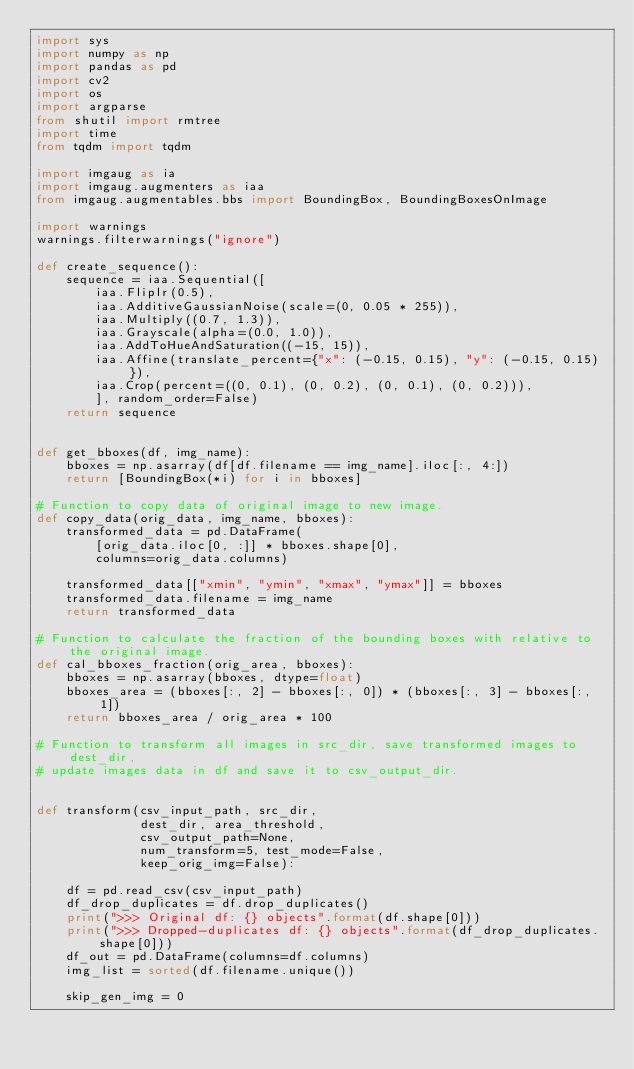<code> <loc_0><loc_0><loc_500><loc_500><_Python_>import sys
import numpy as np
import pandas as pd
import cv2
import os
import argparse
from shutil import rmtree
import time
from tqdm import tqdm

import imgaug as ia
import imgaug.augmenters as iaa
from imgaug.augmentables.bbs import BoundingBox, BoundingBoxesOnImage

import warnings
warnings.filterwarnings("ignore")

def create_sequence():
    sequence = iaa.Sequential([
        iaa.Fliplr(0.5),
        iaa.AdditiveGaussianNoise(scale=(0, 0.05 * 255)),
        iaa.Multiply((0.7, 1.3)),
        iaa.Grayscale(alpha=(0.0, 1.0)),
        iaa.AddToHueAndSaturation((-15, 15)),
        iaa.Affine(translate_percent={"x": (-0.15, 0.15), "y": (-0.15, 0.15)}),
        iaa.Crop(percent=((0, 0.1), (0, 0.2), (0, 0.1), (0, 0.2))),
        ], random_order=False)
    return sequence


def get_bboxes(df, img_name):
    bboxes = np.asarray(df[df.filename == img_name].iloc[:, 4:])
    return [BoundingBox(*i) for i in bboxes]

# Function to copy data of original image to new image.
def copy_data(orig_data, img_name, bboxes):
    transformed_data = pd.DataFrame(
        [orig_data.iloc[0, :]] * bboxes.shape[0],
        columns=orig_data.columns)

    transformed_data[["xmin", "ymin", "xmax", "ymax"]] = bboxes
    transformed_data.filename = img_name
    return transformed_data

# Function to calculate the fraction of the bounding boxes with relative to the original image.
def cal_bboxes_fraction(orig_area, bboxes):
    bboxes = np.asarray(bboxes, dtype=float)
    bboxes_area = (bboxes[:, 2] - bboxes[:, 0]) * (bboxes[:, 3] - bboxes[:, 1])
    return bboxes_area / orig_area * 100

# Function to transform all images in src_dir, save transformed images to dest_dir,
# update images data in df and save it to csv_output_dir.


def transform(csv_input_path, src_dir,
              dest_dir, area_threshold,
              csv_output_path=None,
              num_transform=5, test_mode=False,
              keep_orig_img=False):

    df = pd.read_csv(csv_input_path)
    df_drop_duplicates = df.drop_duplicates()
    print(">>> Original df: {} objects".format(df.shape[0]))
    print(">>> Dropped-duplicates df: {} objects".format(df_drop_duplicates.shape[0]))
    df_out = pd.DataFrame(columns=df.columns)
    img_list = sorted(df.filename.unique())

    skip_gen_img = 0
</code> 